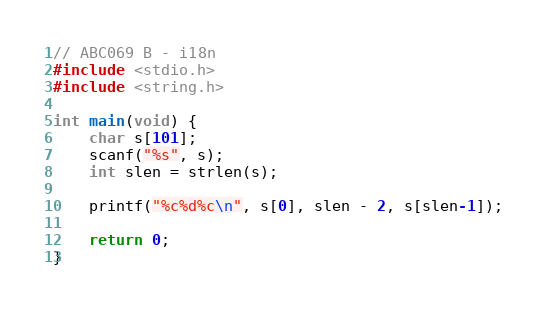Convert code to text. <code><loc_0><loc_0><loc_500><loc_500><_C_>// ABC069 B - i18n
#include <stdio.h>
#include <string.h>

int main(void) {
    char s[101];
    scanf("%s", s);
    int slen = strlen(s);

    printf("%c%d%c\n", s[0], slen - 2, s[slen-1]);

    return 0;
}</code> 